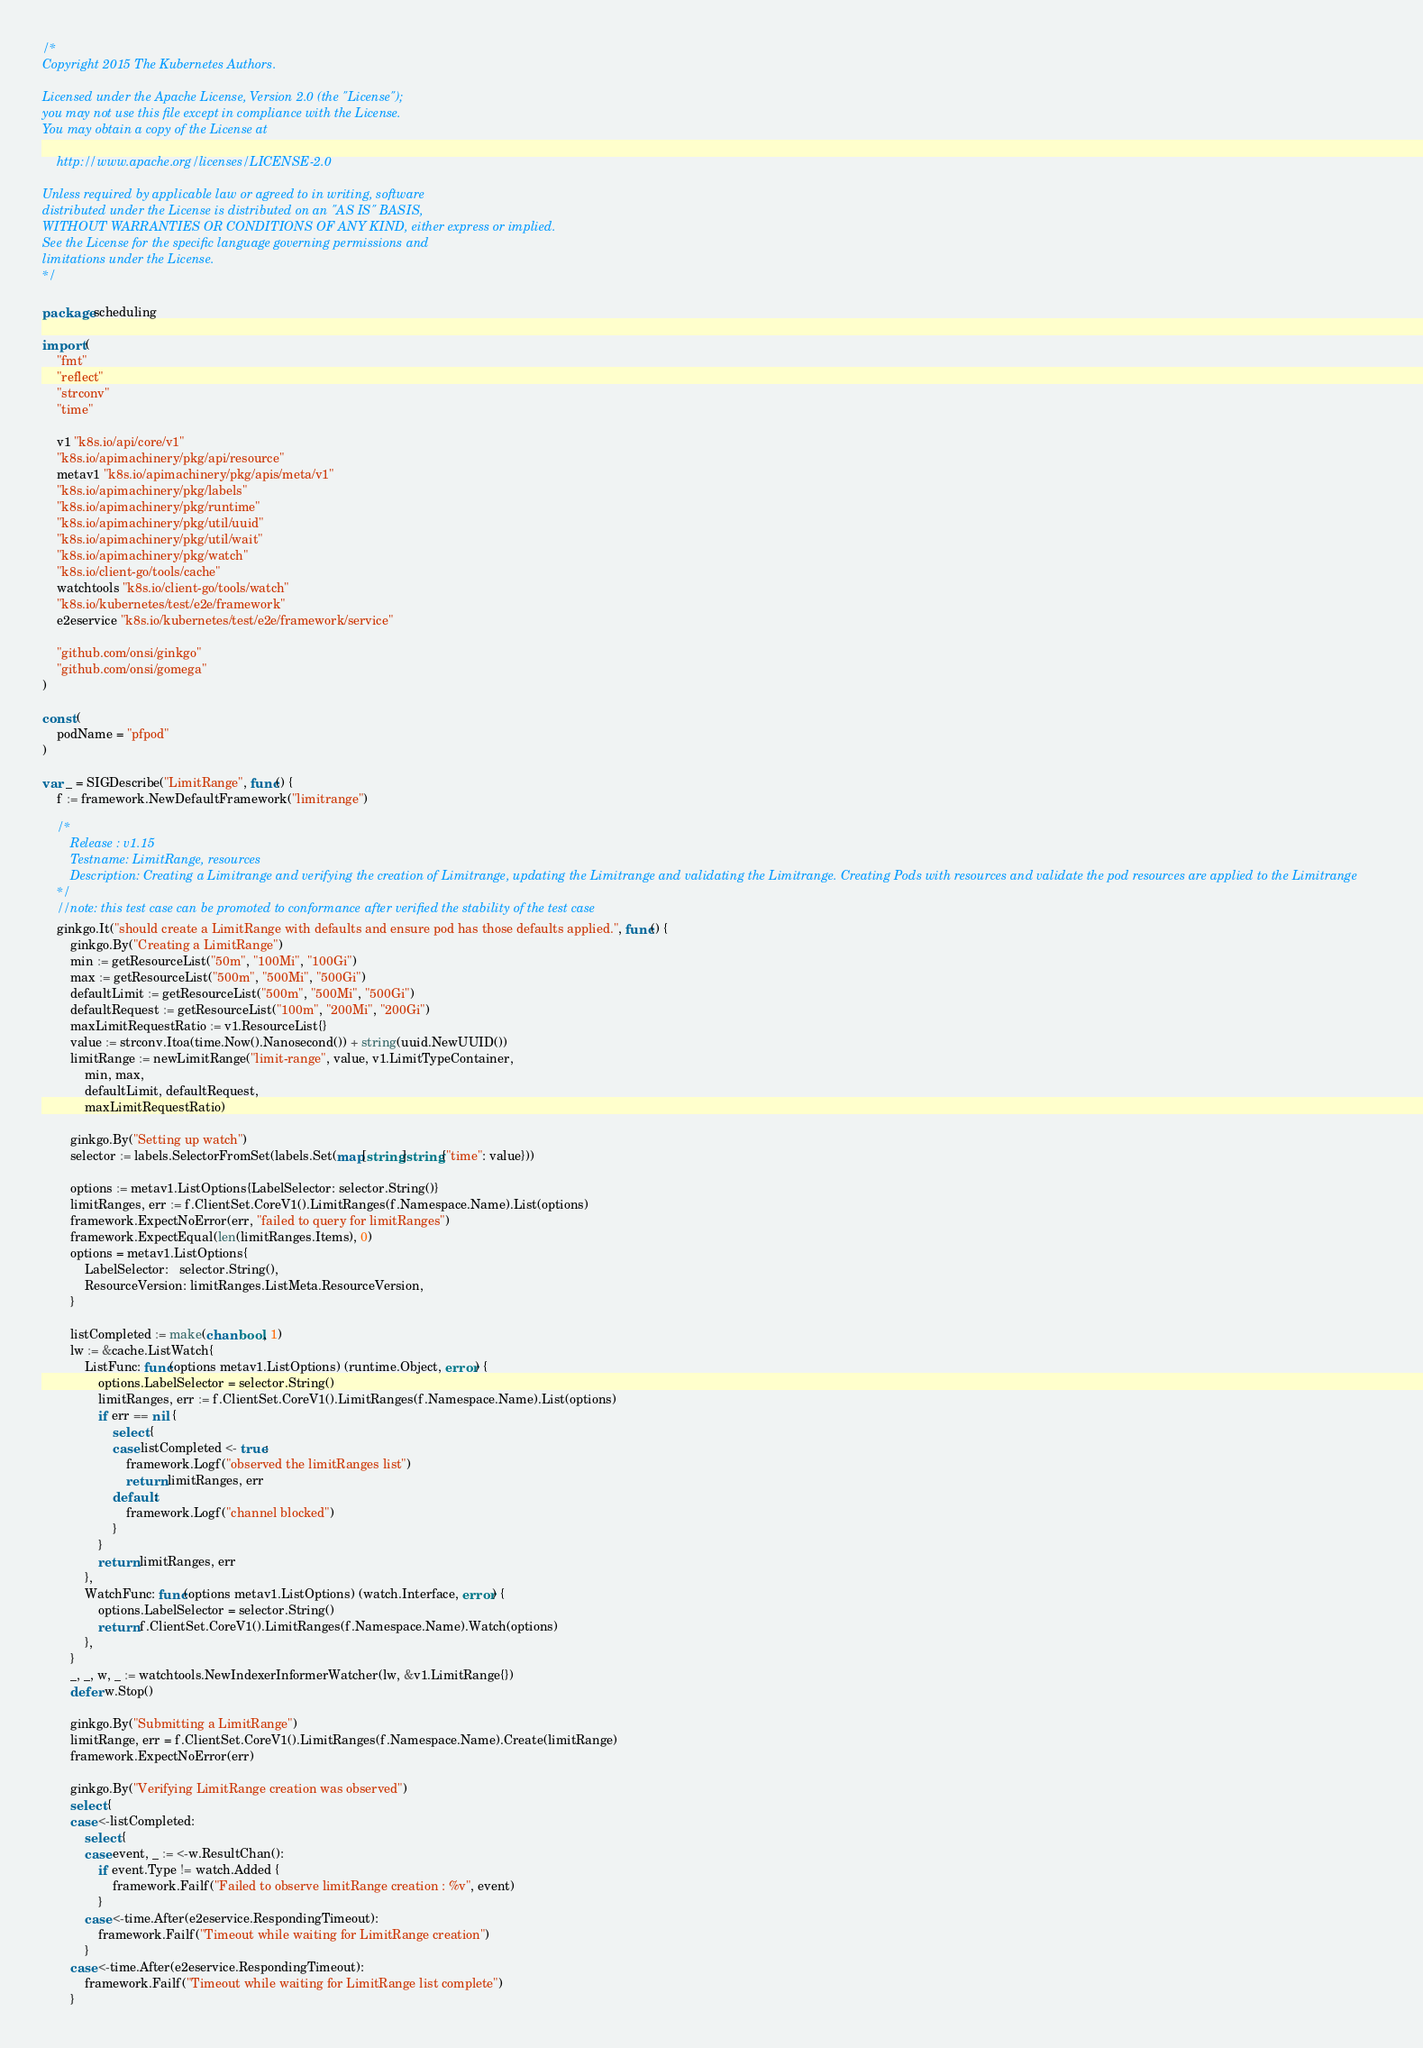<code> <loc_0><loc_0><loc_500><loc_500><_Go_>/*
Copyright 2015 The Kubernetes Authors.

Licensed under the Apache License, Version 2.0 (the "License");
you may not use this file except in compliance with the License.
You may obtain a copy of the License at

    http://www.apache.org/licenses/LICENSE-2.0

Unless required by applicable law or agreed to in writing, software
distributed under the License is distributed on an "AS IS" BASIS,
WITHOUT WARRANTIES OR CONDITIONS OF ANY KIND, either express or implied.
See the License for the specific language governing permissions and
limitations under the License.
*/

package scheduling

import (
	"fmt"
	"reflect"
	"strconv"
	"time"

	v1 "k8s.io/api/core/v1"
	"k8s.io/apimachinery/pkg/api/resource"
	metav1 "k8s.io/apimachinery/pkg/apis/meta/v1"
	"k8s.io/apimachinery/pkg/labels"
	"k8s.io/apimachinery/pkg/runtime"
	"k8s.io/apimachinery/pkg/util/uuid"
	"k8s.io/apimachinery/pkg/util/wait"
	"k8s.io/apimachinery/pkg/watch"
	"k8s.io/client-go/tools/cache"
	watchtools "k8s.io/client-go/tools/watch"
	"k8s.io/kubernetes/test/e2e/framework"
	e2eservice "k8s.io/kubernetes/test/e2e/framework/service"

	"github.com/onsi/ginkgo"
	"github.com/onsi/gomega"
)

const (
	podName = "pfpod"
)

var _ = SIGDescribe("LimitRange", func() {
	f := framework.NewDefaultFramework("limitrange")

	/*
		Release : v1.15
		Testname: LimitRange, resources
		Description: Creating a Limitrange and verifying the creation of Limitrange, updating the Limitrange and validating the Limitrange. Creating Pods with resources and validate the pod resources are applied to the Limitrange
	*/
	//note: this test case can be promoted to conformance after verified the stability of the test case
	ginkgo.It("should create a LimitRange with defaults and ensure pod has those defaults applied.", func() {
		ginkgo.By("Creating a LimitRange")
		min := getResourceList("50m", "100Mi", "100Gi")
		max := getResourceList("500m", "500Mi", "500Gi")
		defaultLimit := getResourceList("500m", "500Mi", "500Gi")
		defaultRequest := getResourceList("100m", "200Mi", "200Gi")
		maxLimitRequestRatio := v1.ResourceList{}
		value := strconv.Itoa(time.Now().Nanosecond()) + string(uuid.NewUUID())
		limitRange := newLimitRange("limit-range", value, v1.LimitTypeContainer,
			min, max,
			defaultLimit, defaultRequest,
			maxLimitRequestRatio)

		ginkgo.By("Setting up watch")
		selector := labels.SelectorFromSet(labels.Set(map[string]string{"time": value}))

		options := metav1.ListOptions{LabelSelector: selector.String()}
		limitRanges, err := f.ClientSet.CoreV1().LimitRanges(f.Namespace.Name).List(options)
		framework.ExpectNoError(err, "failed to query for limitRanges")
		framework.ExpectEqual(len(limitRanges.Items), 0)
		options = metav1.ListOptions{
			LabelSelector:   selector.String(),
			ResourceVersion: limitRanges.ListMeta.ResourceVersion,
		}

		listCompleted := make(chan bool, 1)
		lw := &cache.ListWatch{
			ListFunc: func(options metav1.ListOptions) (runtime.Object, error) {
				options.LabelSelector = selector.String()
				limitRanges, err := f.ClientSet.CoreV1().LimitRanges(f.Namespace.Name).List(options)
				if err == nil {
					select {
					case listCompleted <- true:
						framework.Logf("observed the limitRanges list")
						return limitRanges, err
					default:
						framework.Logf("channel blocked")
					}
				}
				return limitRanges, err
			},
			WatchFunc: func(options metav1.ListOptions) (watch.Interface, error) {
				options.LabelSelector = selector.String()
				return f.ClientSet.CoreV1().LimitRanges(f.Namespace.Name).Watch(options)
			},
		}
		_, _, w, _ := watchtools.NewIndexerInformerWatcher(lw, &v1.LimitRange{})
		defer w.Stop()

		ginkgo.By("Submitting a LimitRange")
		limitRange, err = f.ClientSet.CoreV1().LimitRanges(f.Namespace.Name).Create(limitRange)
		framework.ExpectNoError(err)

		ginkgo.By("Verifying LimitRange creation was observed")
		select {
		case <-listCompleted:
			select {
			case event, _ := <-w.ResultChan():
				if event.Type != watch.Added {
					framework.Failf("Failed to observe limitRange creation : %v", event)
				}
			case <-time.After(e2eservice.RespondingTimeout):
				framework.Failf("Timeout while waiting for LimitRange creation")
			}
		case <-time.After(e2eservice.RespondingTimeout):
			framework.Failf("Timeout while waiting for LimitRange list complete")
		}
</code> 